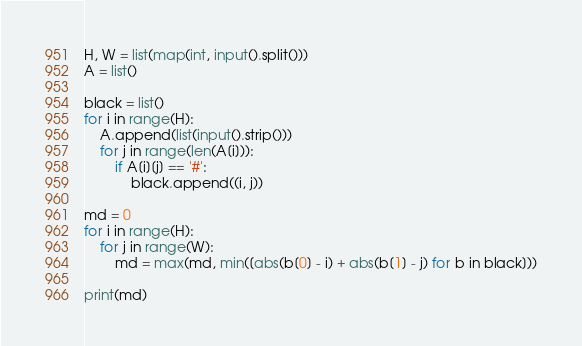<code> <loc_0><loc_0><loc_500><loc_500><_Python_>H, W = list(map(int, input().split()))
A = list()

black = list()
for i in range(H):
    A.append(list(input().strip()))
    for j in range(len(A[i])):
        if A[i][j] == '#':
            black.append((i, j))

md = 0
for i in range(H):
    for j in range(W):
        md = max(md, min([abs(b[0] - i) + abs(b[1] - j) for b in black]))

print(md)</code> 